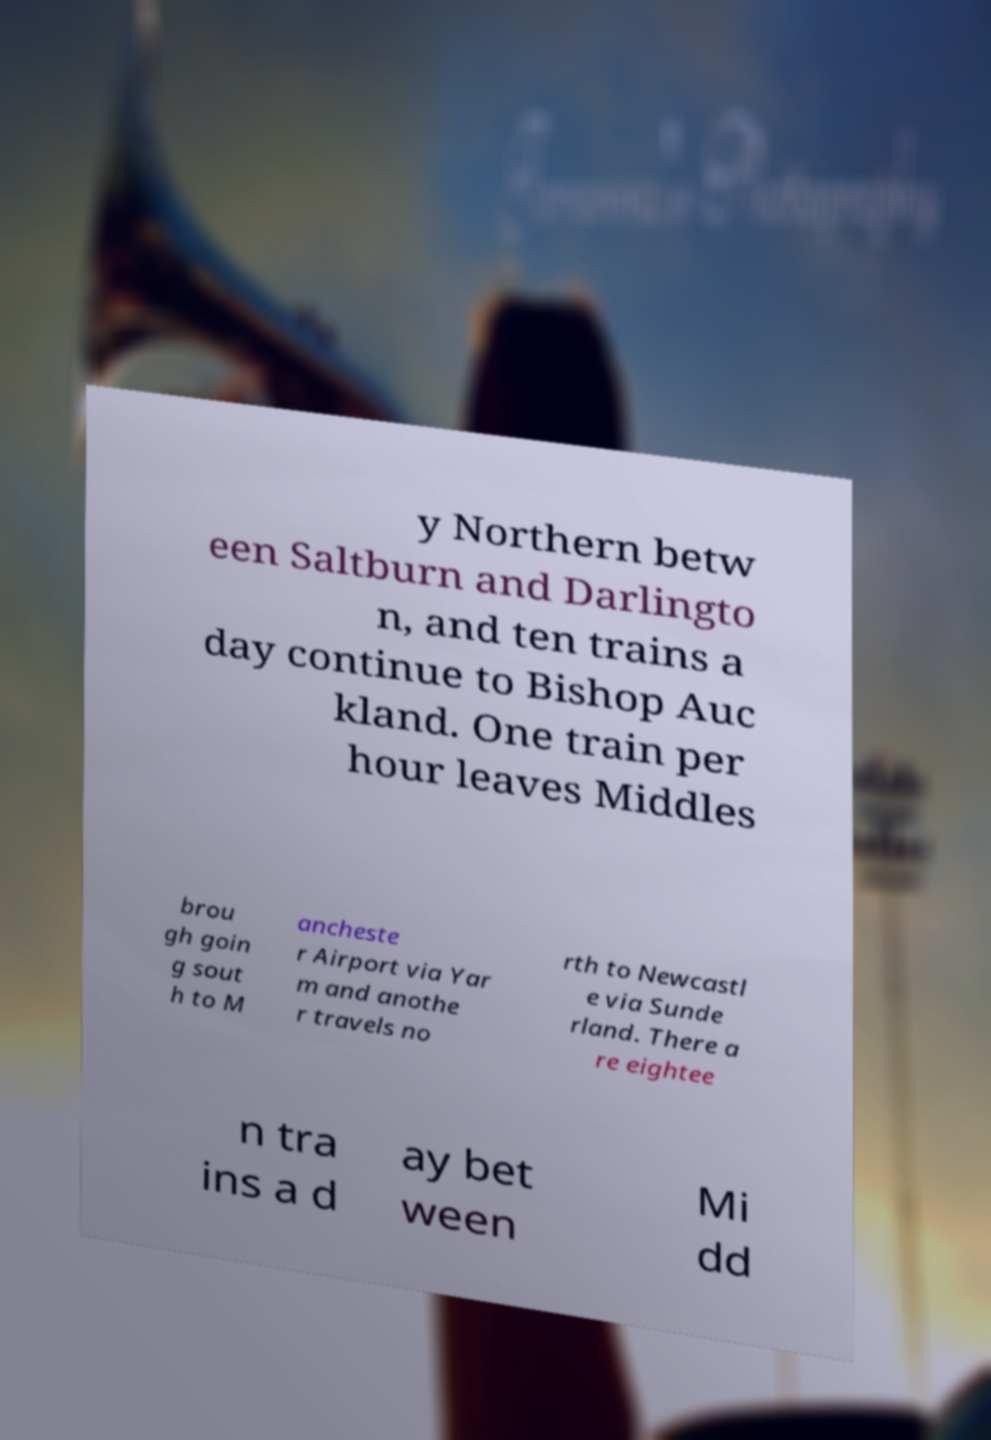Can you accurately transcribe the text from the provided image for me? y Northern betw een Saltburn and Darlingto n, and ten trains a day continue to Bishop Auc kland. One train per hour leaves Middles brou gh goin g sout h to M ancheste r Airport via Yar m and anothe r travels no rth to Newcastl e via Sunde rland. There a re eightee n tra ins a d ay bet ween Mi dd 